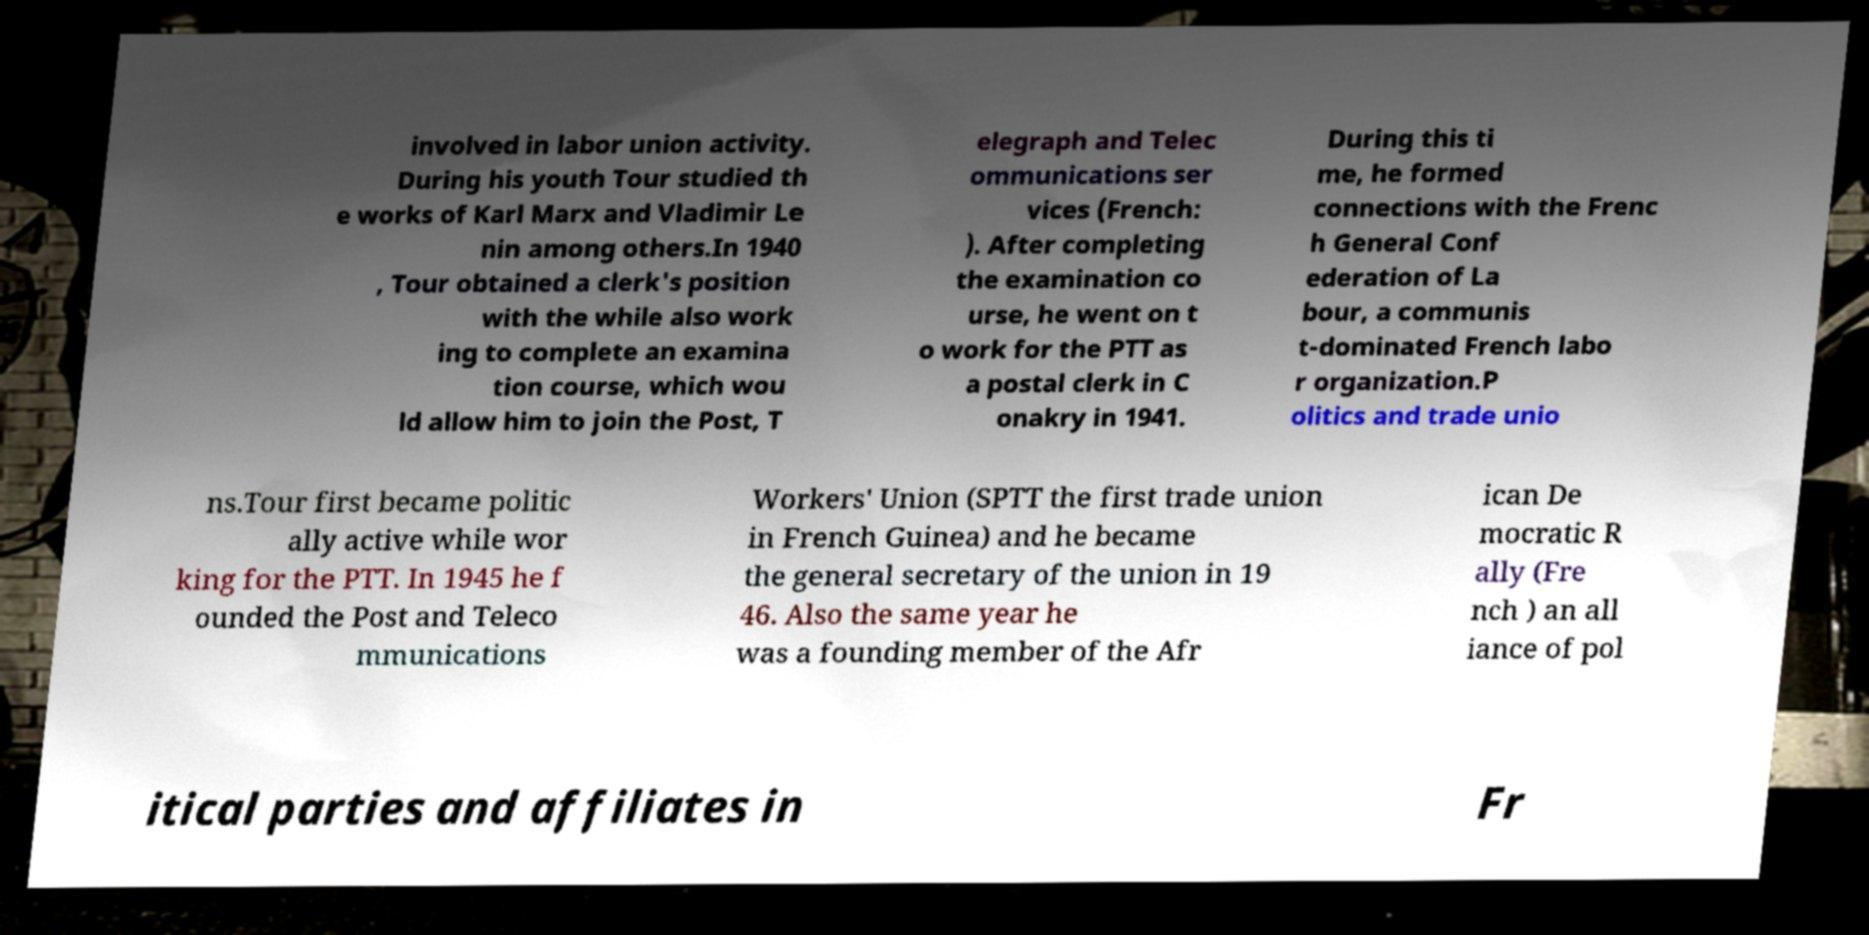What messages or text are displayed in this image? I need them in a readable, typed format. involved in labor union activity. During his youth Tour studied th e works of Karl Marx and Vladimir Le nin among others.In 1940 , Tour obtained a clerk's position with the while also work ing to complete an examina tion course, which wou ld allow him to join the Post, T elegraph and Telec ommunications ser vices (French: ). After completing the examination co urse, he went on t o work for the PTT as a postal clerk in C onakry in 1941. During this ti me, he formed connections with the Frenc h General Conf ederation of La bour, a communis t-dominated French labo r organization.P olitics and trade unio ns.Tour first became politic ally active while wor king for the PTT. In 1945 he f ounded the Post and Teleco mmunications Workers' Union (SPTT the first trade union in French Guinea) and he became the general secretary of the union in 19 46. Also the same year he was a founding member of the Afr ican De mocratic R ally (Fre nch ) an all iance of pol itical parties and affiliates in Fr 